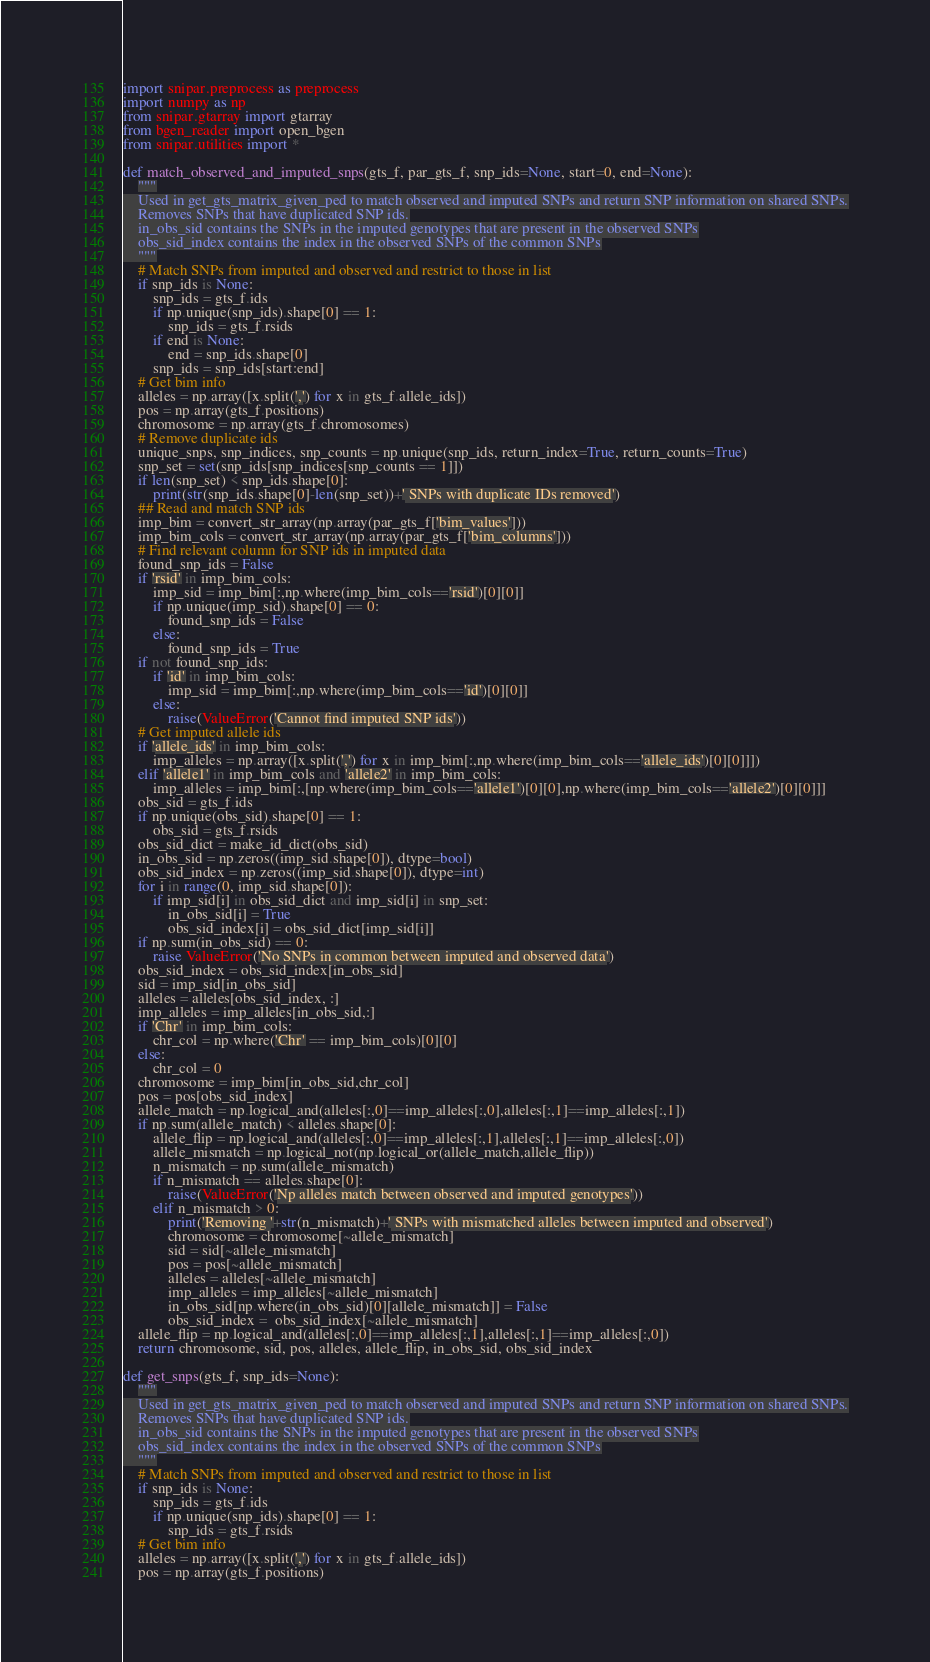<code> <loc_0><loc_0><loc_500><loc_500><_Python_>import snipar.preprocess as preprocess
import numpy as np
from snipar.gtarray import gtarray
from bgen_reader import open_bgen
from snipar.utilities import *

def match_observed_and_imputed_snps(gts_f, par_gts_f, snp_ids=None, start=0, end=None):
    """
    Used in get_gts_matrix_given_ped to match observed and imputed SNPs and return SNP information on shared SNPs.
    Removes SNPs that have duplicated SNP ids.
    in_obs_sid contains the SNPs in the imputed genotypes that are present in the observed SNPs
    obs_sid_index contains the index in the observed SNPs of the common SNPs
    """
    # Match SNPs from imputed and observed and restrict to those in list
    if snp_ids is None:
        snp_ids = gts_f.ids
        if np.unique(snp_ids).shape[0] == 1:
            snp_ids = gts_f.rsids
        if end is None:
            end = snp_ids.shape[0]
        snp_ids = snp_ids[start:end]
    # Get bim info
    alleles = np.array([x.split(',') for x in gts_f.allele_ids])
    pos = np.array(gts_f.positions)
    chromosome = np.array(gts_f.chromosomes)
    # Remove duplicate ids
    unique_snps, snp_indices, snp_counts = np.unique(snp_ids, return_index=True, return_counts=True)
    snp_set = set(snp_ids[snp_indices[snp_counts == 1]])
    if len(snp_set) < snp_ids.shape[0]:
        print(str(snp_ids.shape[0]-len(snp_set))+' SNPs with duplicate IDs removed')
    ## Read and match SNP ids
    imp_bim = convert_str_array(np.array(par_gts_f['bim_values']))
    imp_bim_cols = convert_str_array(np.array(par_gts_f['bim_columns']))
    # Find relevant column for SNP ids in imputed data
    found_snp_ids = False
    if 'rsid' in imp_bim_cols:
        imp_sid = imp_bim[:,np.where(imp_bim_cols=='rsid')[0][0]]
        if np.unique(imp_sid).shape[0] == 0:
            found_snp_ids = False
        else:
            found_snp_ids = True
    if not found_snp_ids:
        if 'id' in imp_bim_cols:
            imp_sid = imp_bim[:,np.where(imp_bim_cols=='id')[0][0]]
        else:
            raise(ValueError('Cannot find imputed SNP ids'))
    # Get imputed allele ids
    if 'allele_ids' in imp_bim_cols:
        imp_alleles = np.array([x.split(',') for x in imp_bim[:,np.where(imp_bim_cols=='allele_ids')[0][0]]])
    elif 'allele1' in imp_bim_cols and 'allele2' in imp_bim_cols:
        imp_alleles = imp_bim[:,[np.where(imp_bim_cols=='allele1')[0][0],np.where(imp_bim_cols=='allele2')[0][0]]]
    obs_sid = gts_f.ids
    if np.unique(obs_sid).shape[0] == 1:
        obs_sid = gts_f.rsids
    obs_sid_dict = make_id_dict(obs_sid)
    in_obs_sid = np.zeros((imp_sid.shape[0]), dtype=bool)
    obs_sid_index = np.zeros((imp_sid.shape[0]), dtype=int)
    for i in range(0, imp_sid.shape[0]):
        if imp_sid[i] in obs_sid_dict and imp_sid[i] in snp_set:
            in_obs_sid[i] = True
            obs_sid_index[i] = obs_sid_dict[imp_sid[i]]
    if np.sum(in_obs_sid) == 0:
        raise ValueError('No SNPs in common between imputed and observed data')
    obs_sid_index = obs_sid_index[in_obs_sid]
    sid = imp_sid[in_obs_sid]
    alleles = alleles[obs_sid_index, :]
    imp_alleles = imp_alleles[in_obs_sid,:]
    if 'Chr' in imp_bim_cols:
        chr_col = np.where('Chr' == imp_bim_cols)[0][0]
    else:
        chr_col = 0
    chromosome = imp_bim[in_obs_sid,chr_col]
    pos = pos[obs_sid_index]
    allele_match = np.logical_and(alleles[:,0]==imp_alleles[:,0],alleles[:,1]==imp_alleles[:,1])
    if np.sum(allele_match) < alleles.shape[0]:
        allele_flip = np.logical_and(alleles[:,0]==imp_alleles[:,1],alleles[:,1]==imp_alleles[:,0])
        allele_mismatch = np.logical_not(np.logical_or(allele_match,allele_flip))
        n_mismatch = np.sum(allele_mismatch)
        if n_mismatch == alleles.shape[0]:
            raise(ValueError('Np alleles match between observed and imputed genotypes'))
        elif n_mismatch > 0:
            print('Removing '+str(n_mismatch)+' SNPs with mismatched alleles between imputed and observed')
            chromosome = chromosome[~allele_mismatch]
            sid = sid[~allele_mismatch]
            pos = pos[~allele_mismatch]
            alleles = alleles[~allele_mismatch]
            imp_alleles = imp_alleles[~allele_mismatch]
            in_obs_sid[np.where(in_obs_sid)[0][allele_mismatch]] = False
            obs_sid_index =  obs_sid_index[~allele_mismatch]
    allele_flip = np.logical_and(alleles[:,0]==imp_alleles[:,1],alleles[:,1]==imp_alleles[:,0])
    return chromosome, sid, pos, alleles, allele_flip, in_obs_sid, obs_sid_index

def get_snps(gts_f, snp_ids=None):
    """
    Used in get_gts_matrix_given_ped to match observed and imputed SNPs and return SNP information on shared SNPs.
    Removes SNPs that have duplicated SNP ids.
    in_obs_sid contains the SNPs in the imputed genotypes that are present in the observed SNPs
    obs_sid_index contains the index in the observed SNPs of the common SNPs
    """
    # Match SNPs from imputed and observed and restrict to those in list
    if snp_ids is None:
        snp_ids = gts_f.ids
        if np.unique(snp_ids).shape[0] == 1:
            snp_ids = gts_f.rsids
    # Get bim info
    alleles = np.array([x.split(',') for x in gts_f.allele_ids])
    pos = np.array(gts_f.positions)</code> 